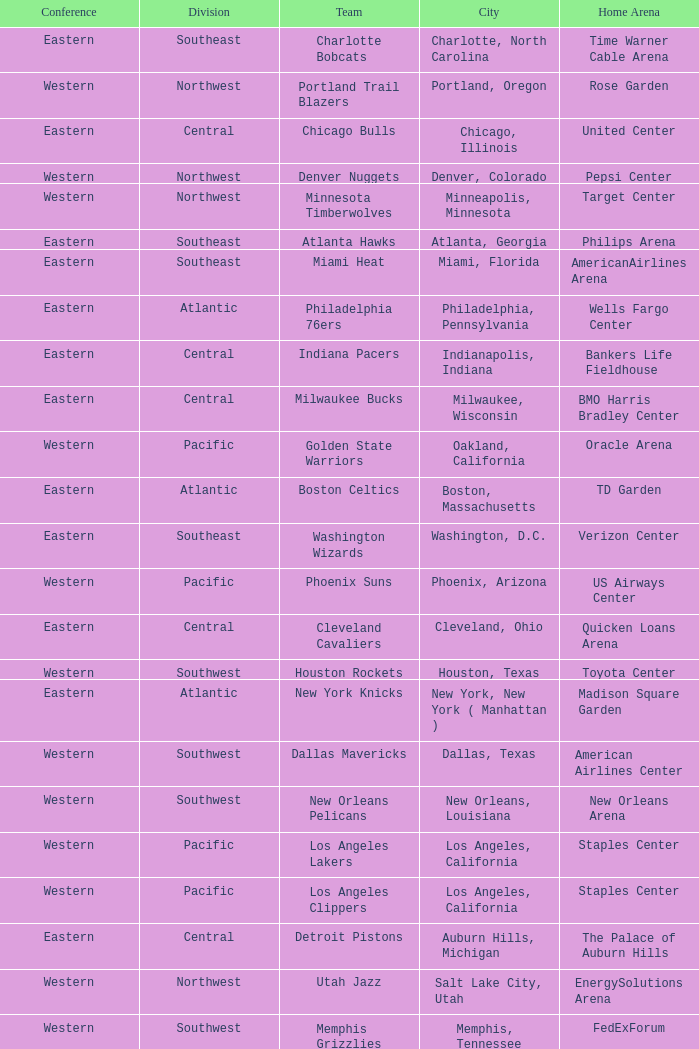Which conference is in Portland, Oregon? Western. 